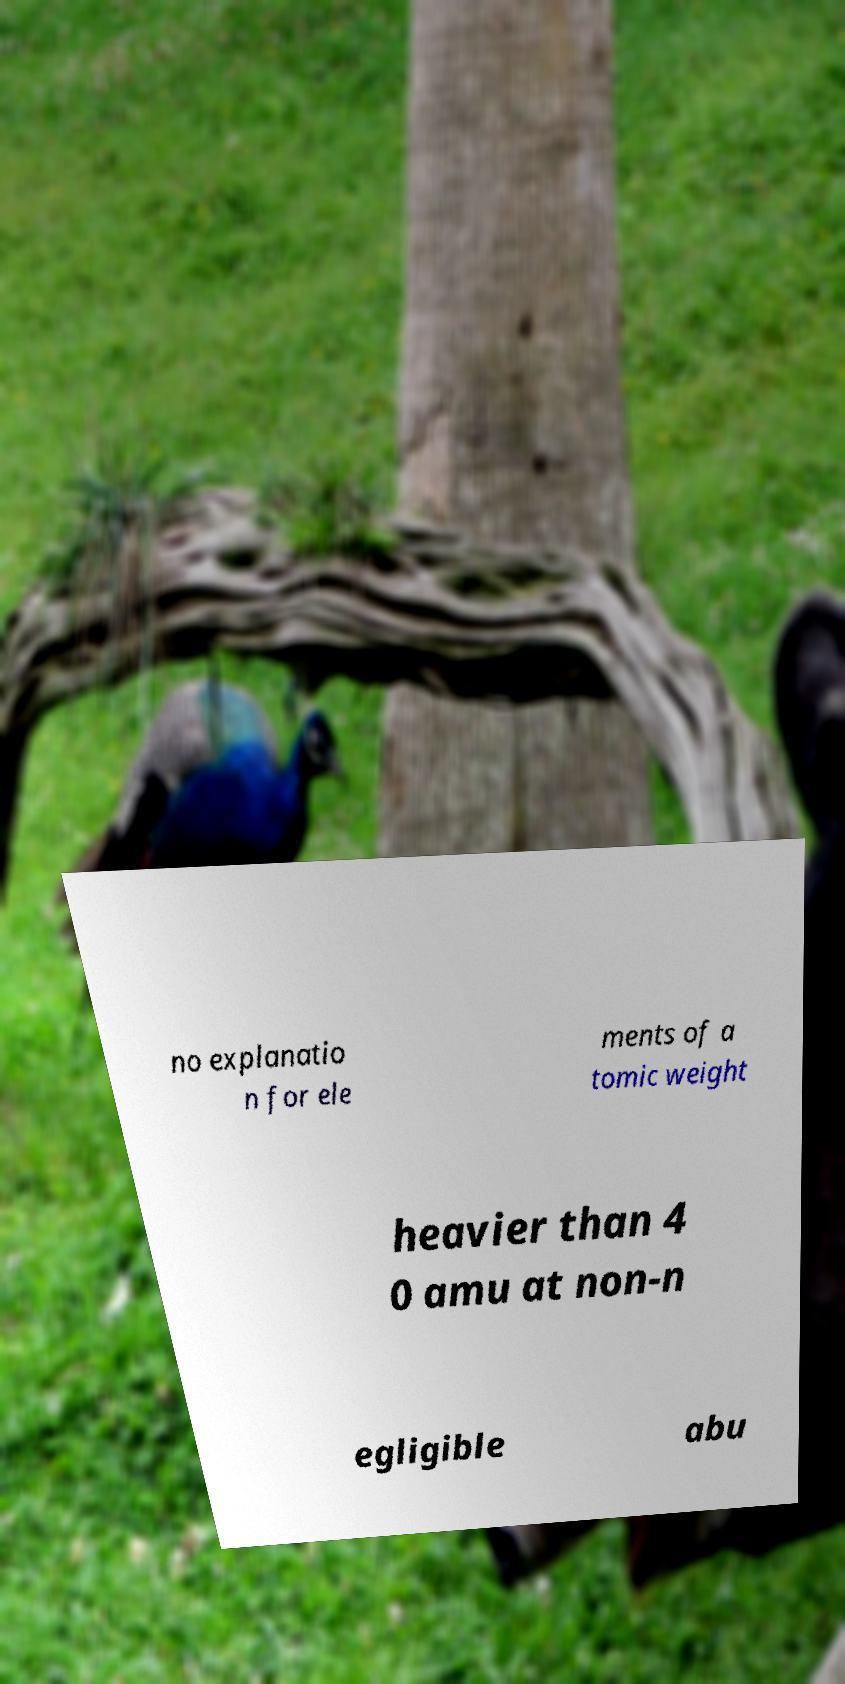What messages or text are displayed in this image? I need them in a readable, typed format. no explanatio n for ele ments of a tomic weight heavier than 4 0 amu at non-n egligible abu 